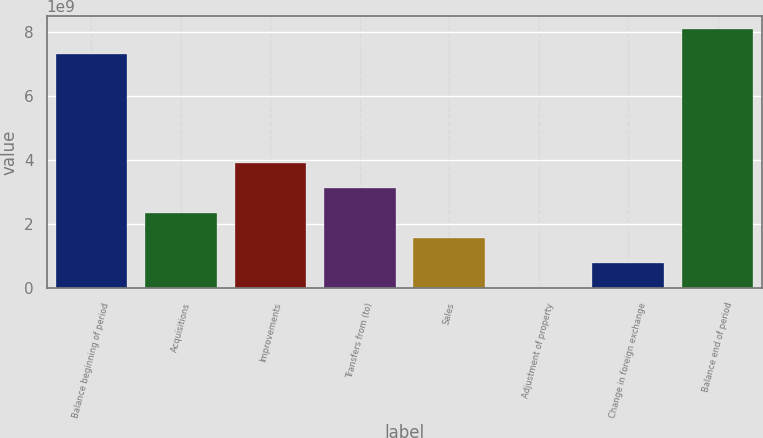<chart> <loc_0><loc_0><loc_500><loc_500><bar_chart><fcel>Balance beginning of period<fcel>Acquisitions<fcel>Improvements<fcel>Transfers from (to)<fcel>Sales<fcel>Adjustment of property<fcel>Change in foreign exchange<fcel>Balance end of period<nl><fcel>7.32503e+09<fcel>2.3512e+09<fcel>3.91341e+09<fcel>3.13231e+09<fcel>1.5701e+09<fcel>7.9e+06<fcel>7.89002e+08<fcel>8.10614e+09<nl></chart> 